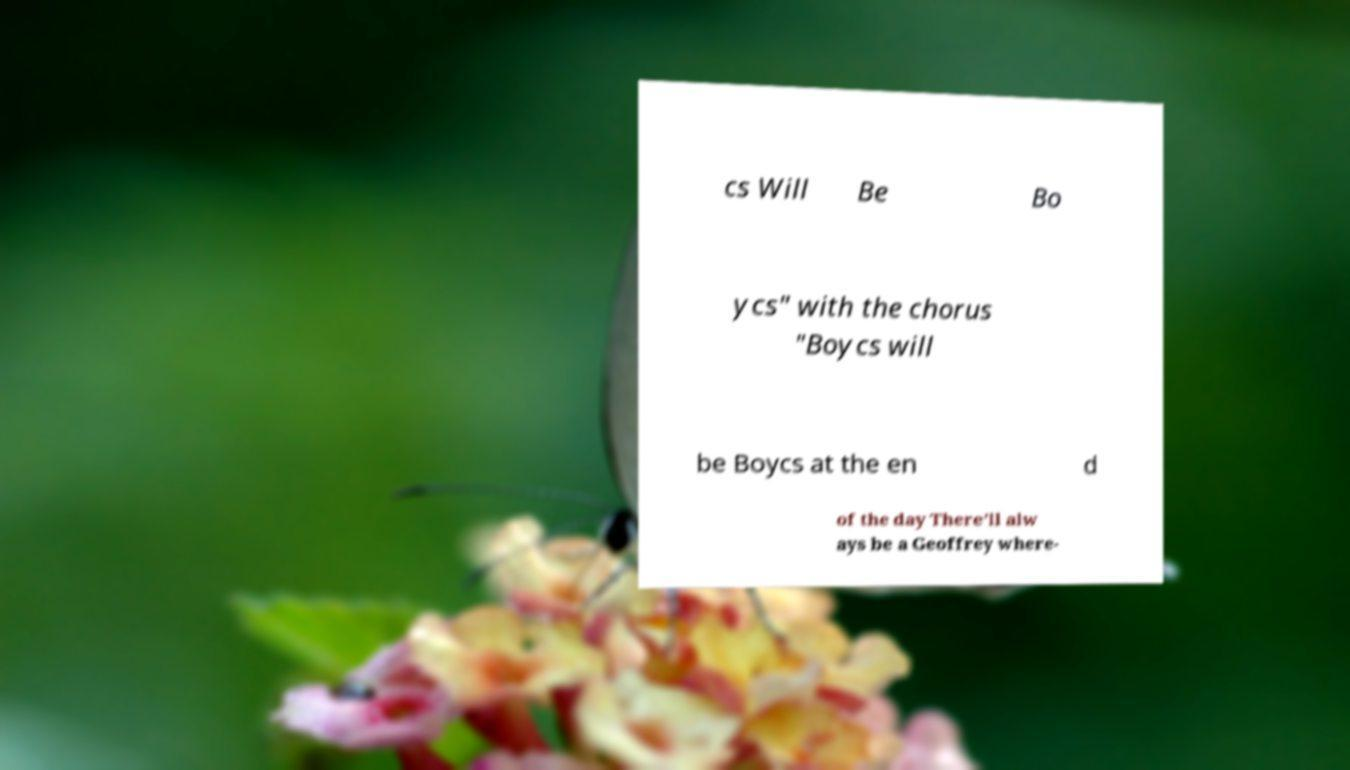Please identify and transcribe the text found in this image. cs Will Be Bo ycs" with the chorus "Boycs will be Boycs at the en d of the day There'll alw ays be a Geoffrey where- 